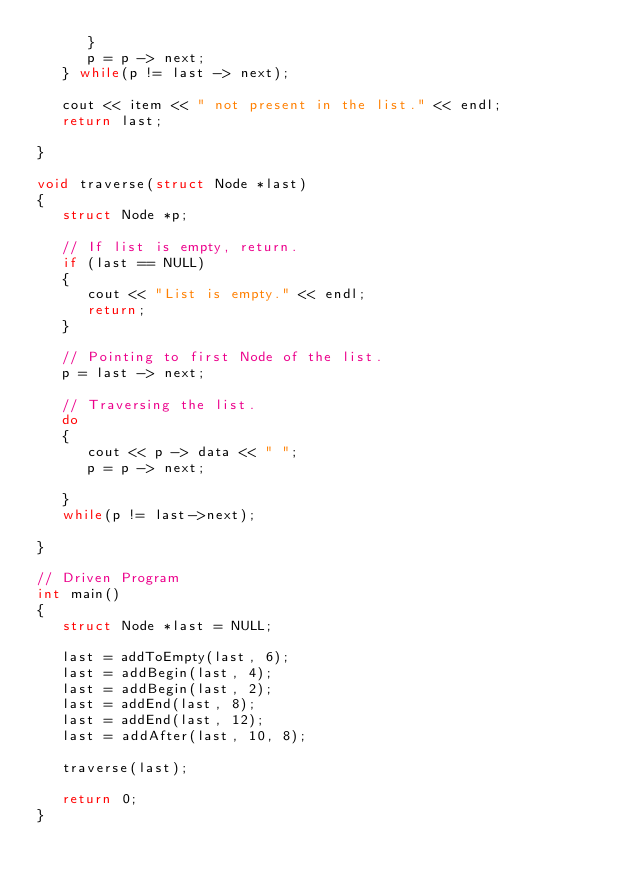<code> <loc_0><loc_0><loc_500><loc_500><_C++_>      }
      p = p -> next;
   } while(p != last -> next);

   cout << item << " not present in the list." << endl;
   return last;

}

void traverse(struct Node *last)
{
   struct Node *p;

   // If list is empty, return.
   if (last == NULL)
   {
      cout << "List is empty." << endl;
      return;
   }

   // Pointing to first Node of the list.
   p = last -> next;

   // Traversing the list.
   do
   {
      cout << p -> data << " ";
      p = p -> next;

   }
   while(p != last->next);

}

// Driven Program
int main()
{
   struct Node *last = NULL;

   last = addToEmpty(last, 6);
   last = addBegin(last, 4);
   last = addBegin(last, 2);
   last = addEnd(last, 8);
   last = addEnd(last, 12);
   last = addAfter(last, 10, 8);

   traverse(last);

   return 0;
}
</code> 